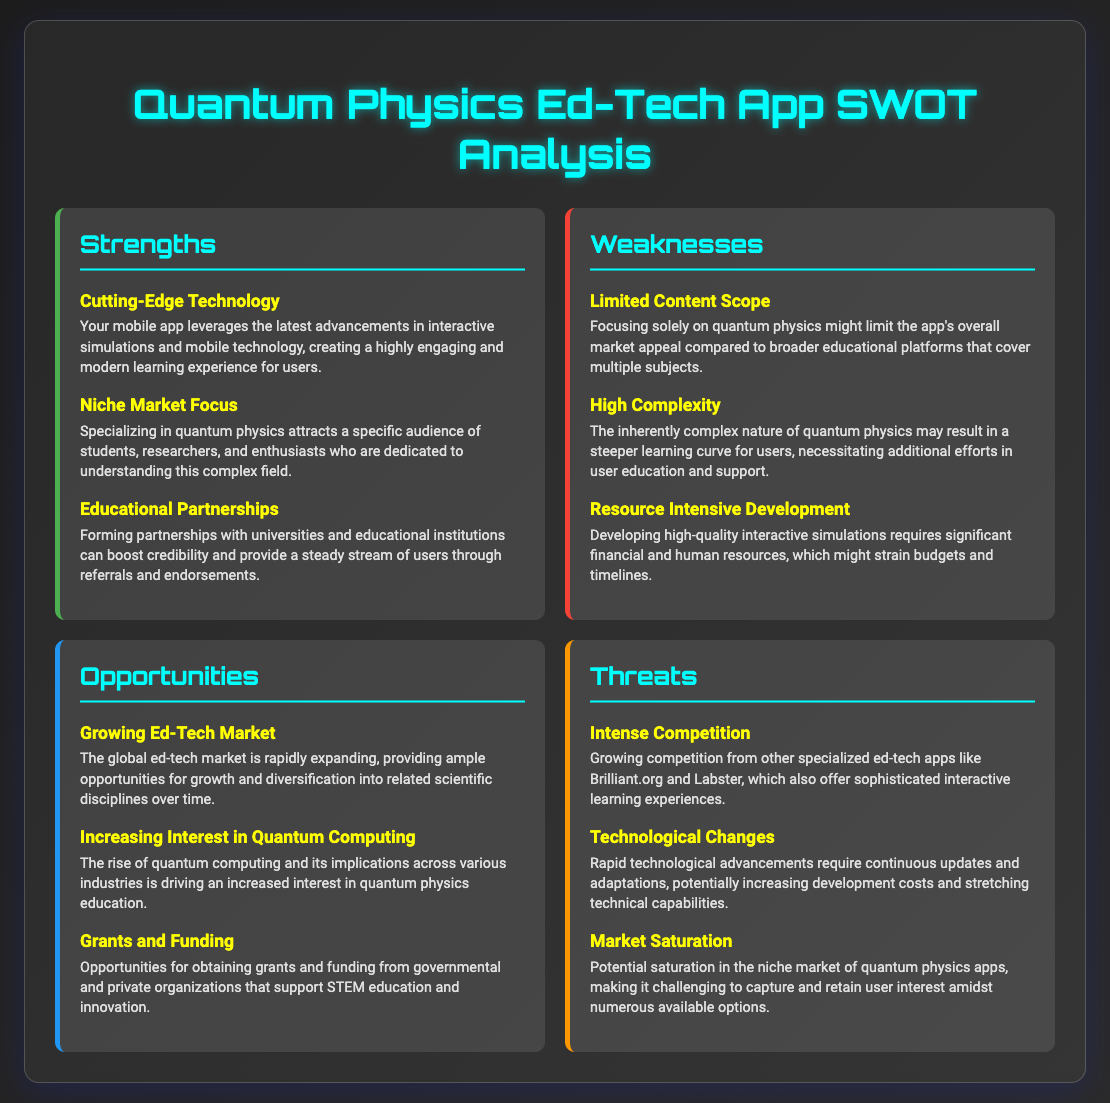What is the title of the document? The title of the document is found at the top of the rendered HTML and provides the main topic of discussion, which is "Quantum Physics Ed-Tech App SWOT Analysis."
Answer: Quantum Physics Ed-Tech App SWOT Analysis How many strengths are listed? The number of strengths can be counted from the strength section of the document, where three distinct strengths are mentioned.
Answer: 3 What is one key opportunity in the document? The key opportunities are listed in the opportunities section, and one of them is "Growing Ed-Tech Market."
Answer: Growing Ed-Tech Market What is a weakness related to app content? The weaknesses section includes specific weaknesses, and one directly related to content is "Limited Content Scope."
Answer: Limited Content Scope Which threat involves competition? The threats section mentions several potential threats, one of which is related to competition is "Intense Competition."
Answer: Intense Competition What is a cited technological threat? The threats section outlines various issues with technology, specifically noting "Technological Changes."
Answer: Technological Changes Which educational strategy is highlighted as a strength? The document discusses partnerships and notes that "Educational Partnerships" is a strength contributing to credibility.
Answer: Educational Partnerships How many opportunities are mentioned? The opportunities section contains three opportunities, showcasing growth potential in different areas.
Answer: 3 